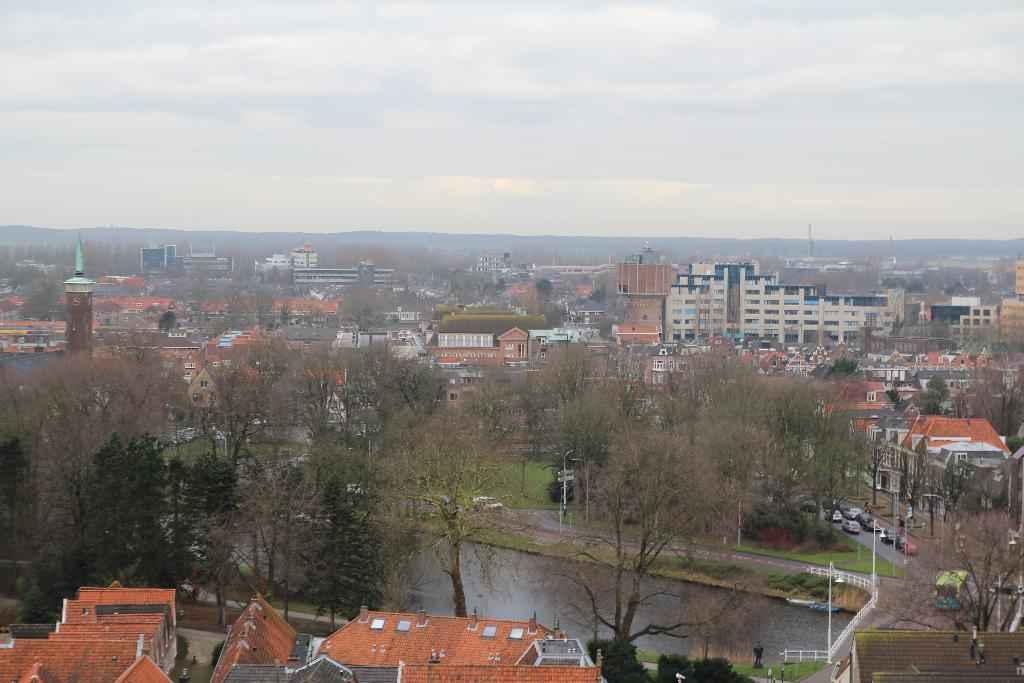What is the perspective of the image? The image shows a top view of a city. What types of structures can be seen in the city? There are many buildings and houses in the city. Are there any natural elements present in the city? Yes, trees are present in the city. What is happening on the roads in the city? Vehicles are visible on the roads. What is the color of the sky in the image? The sky is blue in the image. Can you point out the tramp performing in the city square in the image? There is no tramp performing in the city square in the image. What type of office can be seen in the image? There is no specific office building mentioned or visible in the image; it shows a general view of the city with various buildings and houses. 